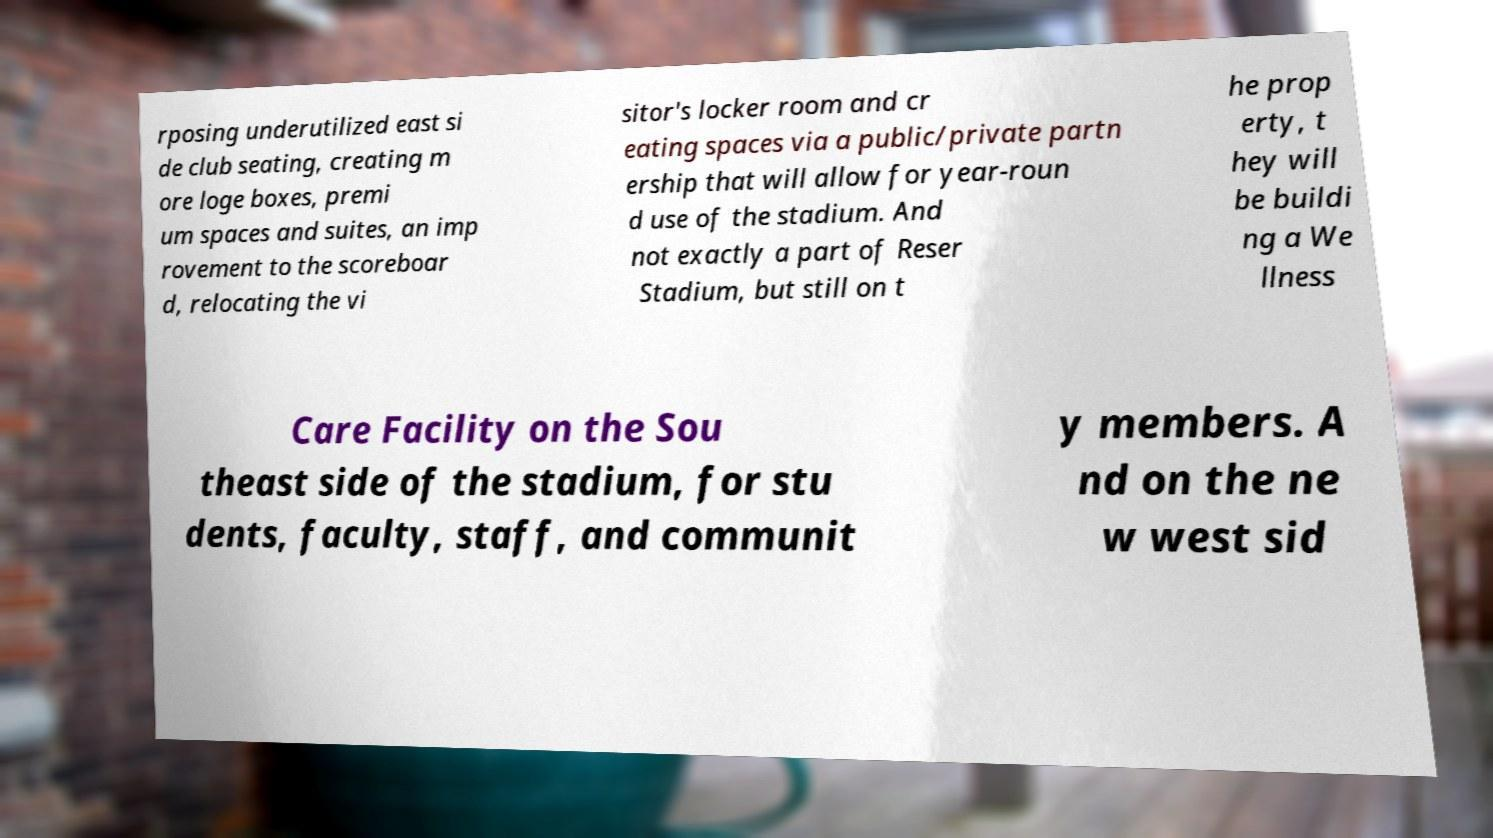What messages or text are displayed in this image? I need them in a readable, typed format. rposing underutilized east si de club seating, creating m ore loge boxes, premi um spaces and suites, an imp rovement to the scoreboar d, relocating the vi sitor's locker room and cr eating spaces via a public/private partn ership that will allow for year-roun d use of the stadium. And not exactly a part of Reser Stadium, but still on t he prop erty, t hey will be buildi ng a We llness Care Facility on the Sou theast side of the stadium, for stu dents, faculty, staff, and communit y members. A nd on the ne w west sid 